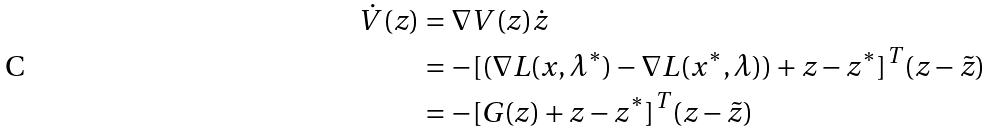<formula> <loc_0><loc_0><loc_500><loc_500>\dot { V } ( z ) & = \nabla V ( z ) \dot { z } \\ & = - [ ( \nabla { L } ( x , \lambda ^ { * } ) - \nabla { L } ( x ^ { * } , \lambda ) ) + z - z ^ { * } ] ^ { T } ( z - \tilde { z } ) \\ & = - [ G ( z ) + z - z ^ { * } ] ^ { T } ( z - \tilde { z } )</formula> 